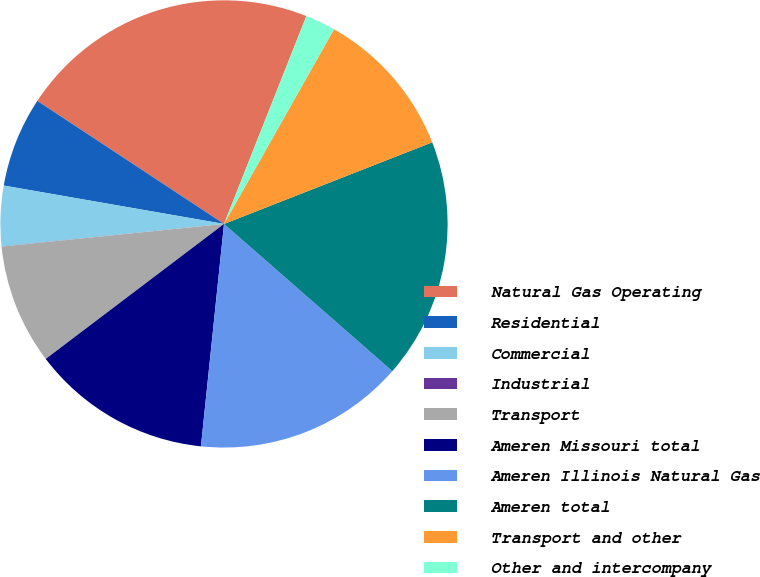Convert chart. <chart><loc_0><loc_0><loc_500><loc_500><pie_chart><fcel>Natural Gas Operating<fcel>Residential<fcel>Commercial<fcel>Industrial<fcel>Transport<fcel>Ameren Missouri total<fcel>Ameren Illinois Natural Gas<fcel>Ameren total<fcel>Transport and other<fcel>Other and intercompany<nl><fcel>21.73%<fcel>6.53%<fcel>4.35%<fcel>0.01%<fcel>8.7%<fcel>13.04%<fcel>15.21%<fcel>17.38%<fcel>10.87%<fcel>2.18%<nl></chart> 